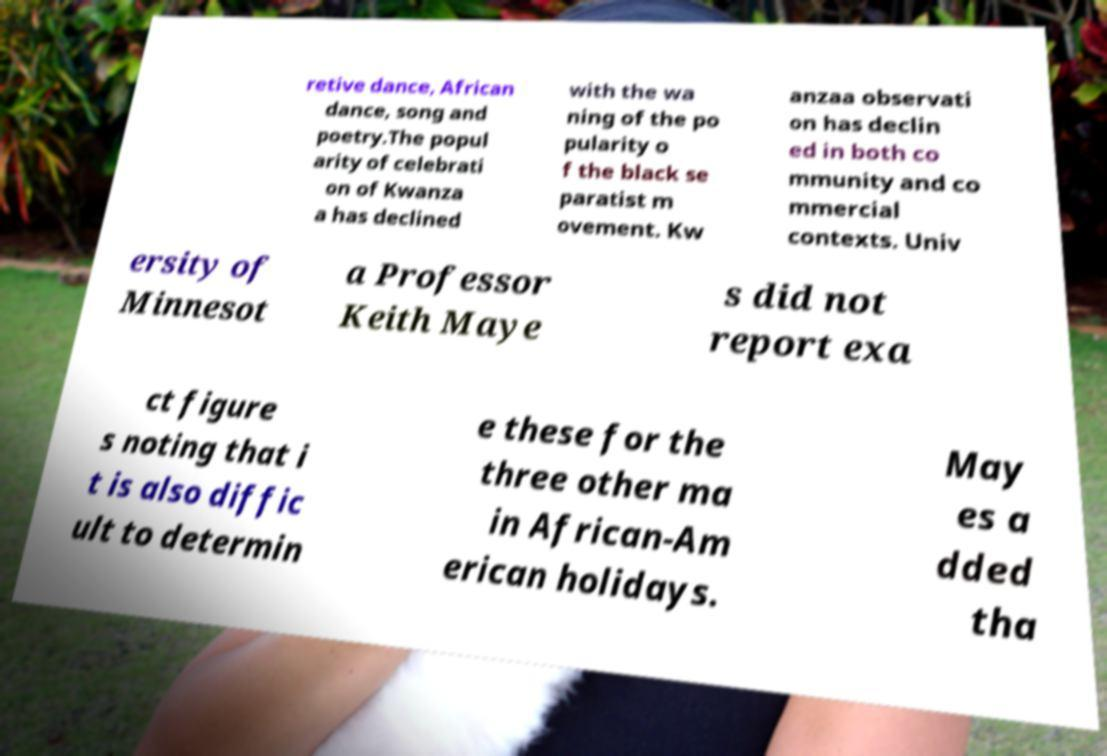I need the written content from this picture converted into text. Can you do that? retive dance, African dance, song and poetry.The popul arity of celebrati on of Kwanza a has declined with the wa ning of the po pularity o f the black se paratist m ovement. Kw anzaa observati on has declin ed in both co mmunity and co mmercial contexts. Univ ersity of Minnesot a Professor Keith Maye s did not report exa ct figure s noting that i t is also diffic ult to determin e these for the three other ma in African-Am erican holidays. May es a dded tha 